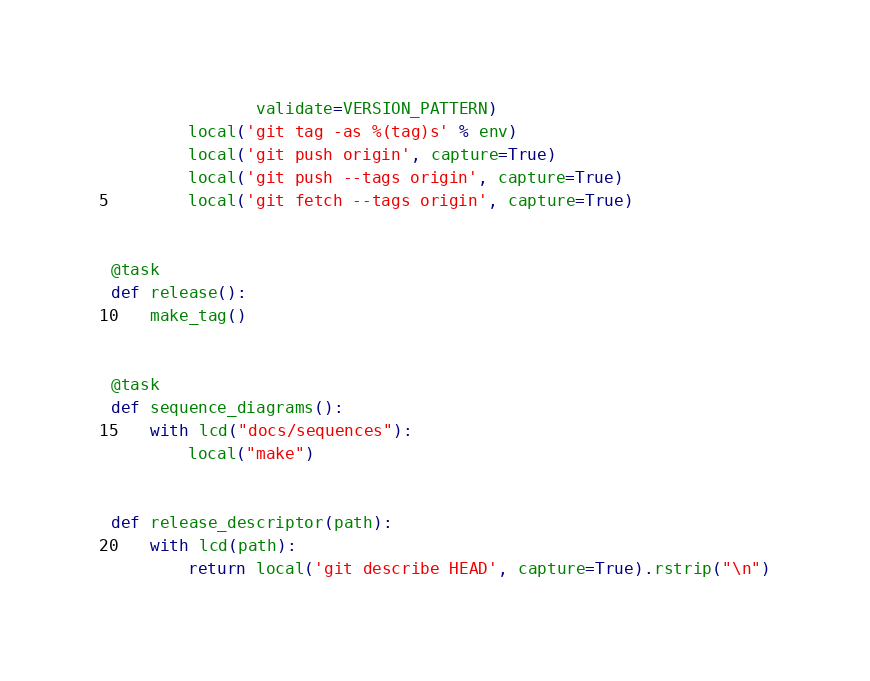<code> <loc_0><loc_0><loc_500><loc_500><_Python_>               validate=VERSION_PATTERN)
        local('git tag -as %(tag)s' % env)
        local('git push origin', capture=True)
        local('git push --tags origin', capture=True)
        local('git fetch --tags origin', capture=True)


@task
def release():
    make_tag()


@task
def sequence_diagrams():
    with lcd("docs/sequences"):
        local("make")


def release_descriptor(path):
    with lcd(path):
        return local('git describe HEAD', capture=True).rstrip("\n")
</code> 